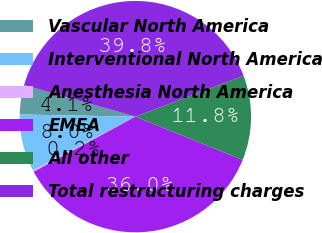Convert chart. <chart><loc_0><loc_0><loc_500><loc_500><pie_chart><fcel>Vascular North America<fcel>Interventional North America<fcel>Anesthesia North America<fcel>EMEA<fcel>All other<fcel>Total restructuring charges<nl><fcel>4.11%<fcel>7.97%<fcel>0.24%<fcel>35.99%<fcel>11.84%<fcel>39.85%<nl></chart> 